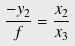Convert formula to latex. <formula><loc_0><loc_0><loc_500><loc_500>\frac { - y _ { 2 } } { f } = \frac { x _ { 2 } } { x _ { 3 } }</formula> 